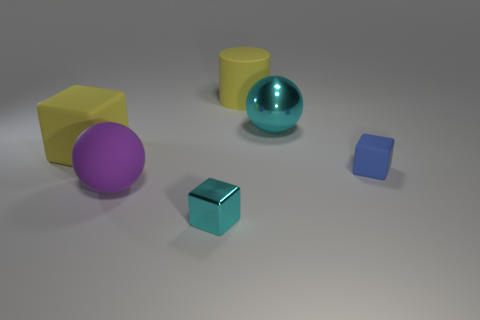Subtract all small rubber cubes. How many cubes are left? 2 Add 1 brown shiny things. How many objects exist? 7 Subtract all spheres. How many objects are left? 4 Subtract all blue cubes. How many cubes are left? 2 Add 3 yellow things. How many yellow things are left? 5 Add 3 tiny red cubes. How many tiny red cubes exist? 3 Subtract 0 gray balls. How many objects are left? 6 Subtract 2 spheres. How many spheres are left? 0 Subtract all green blocks. Subtract all blue spheres. How many blocks are left? 3 Subtract all red balls. How many brown cylinders are left? 0 